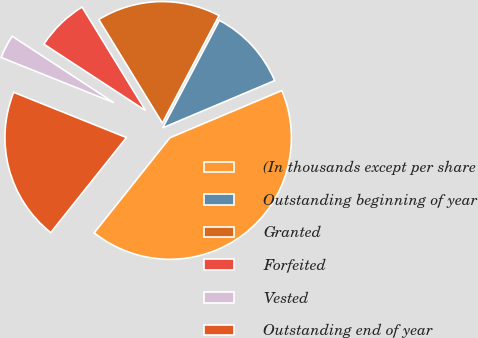Convert chart. <chart><loc_0><loc_0><loc_500><loc_500><pie_chart><fcel>(In thousands except per share<fcel>Outstanding beginning of year<fcel>Granted<fcel>Forfeited<fcel>Vested<fcel>Outstanding end of year<nl><fcel>42.06%<fcel>10.92%<fcel>16.48%<fcel>7.03%<fcel>3.14%<fcel>20.37%<nl></chart> 